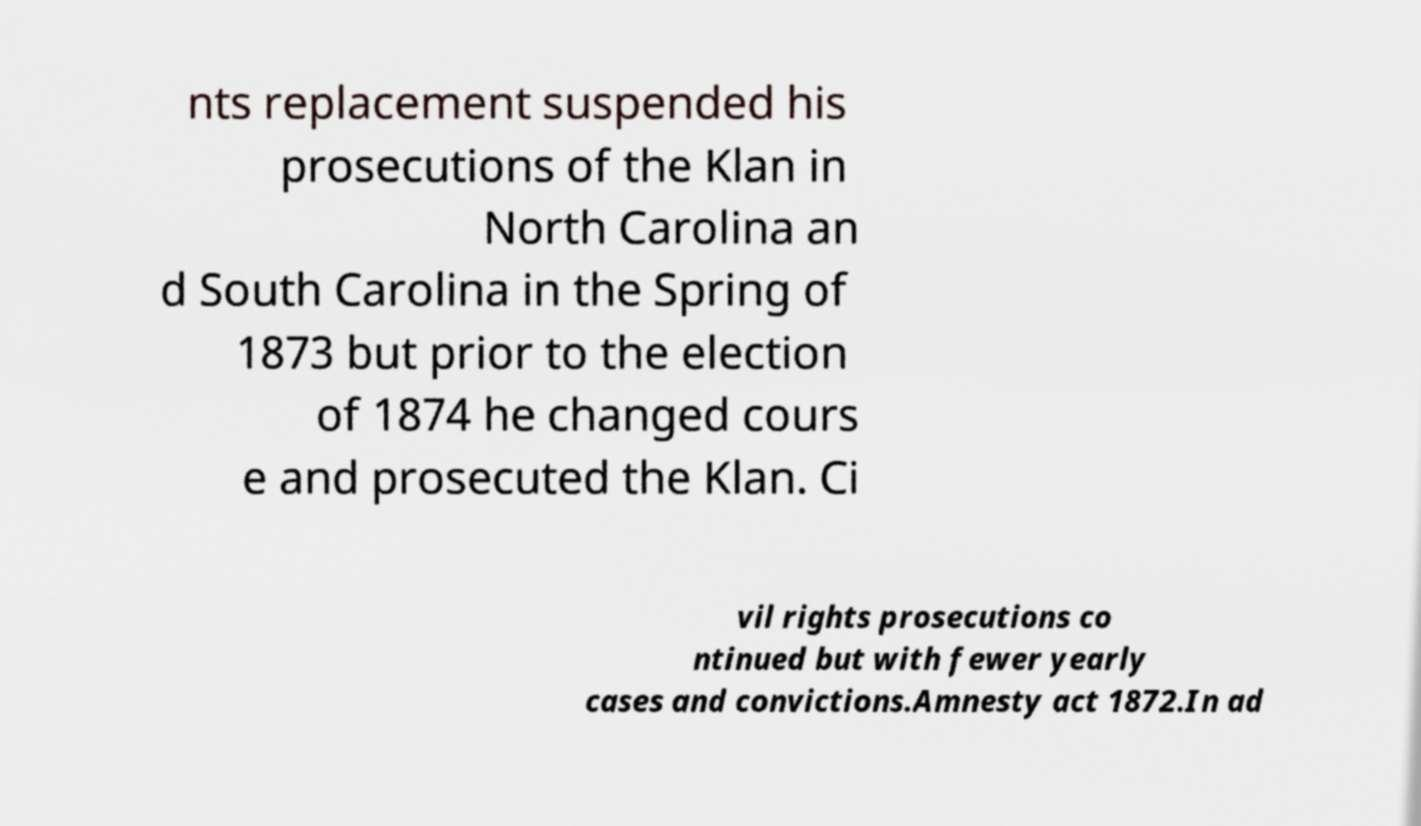Could you assist in decoding the text presented in this image and type it out clearly? nts replacement suspended his prosecutions of the Klan in North Carolina an d South Carolina in the Spring of 1873 but prior to the election of 1874 he changed cours e and prosecuted the Klan. Ci vil rights prosecutions co ntinued but with fewer yearly cases and convictions.Amnesty act 1872.In ad 